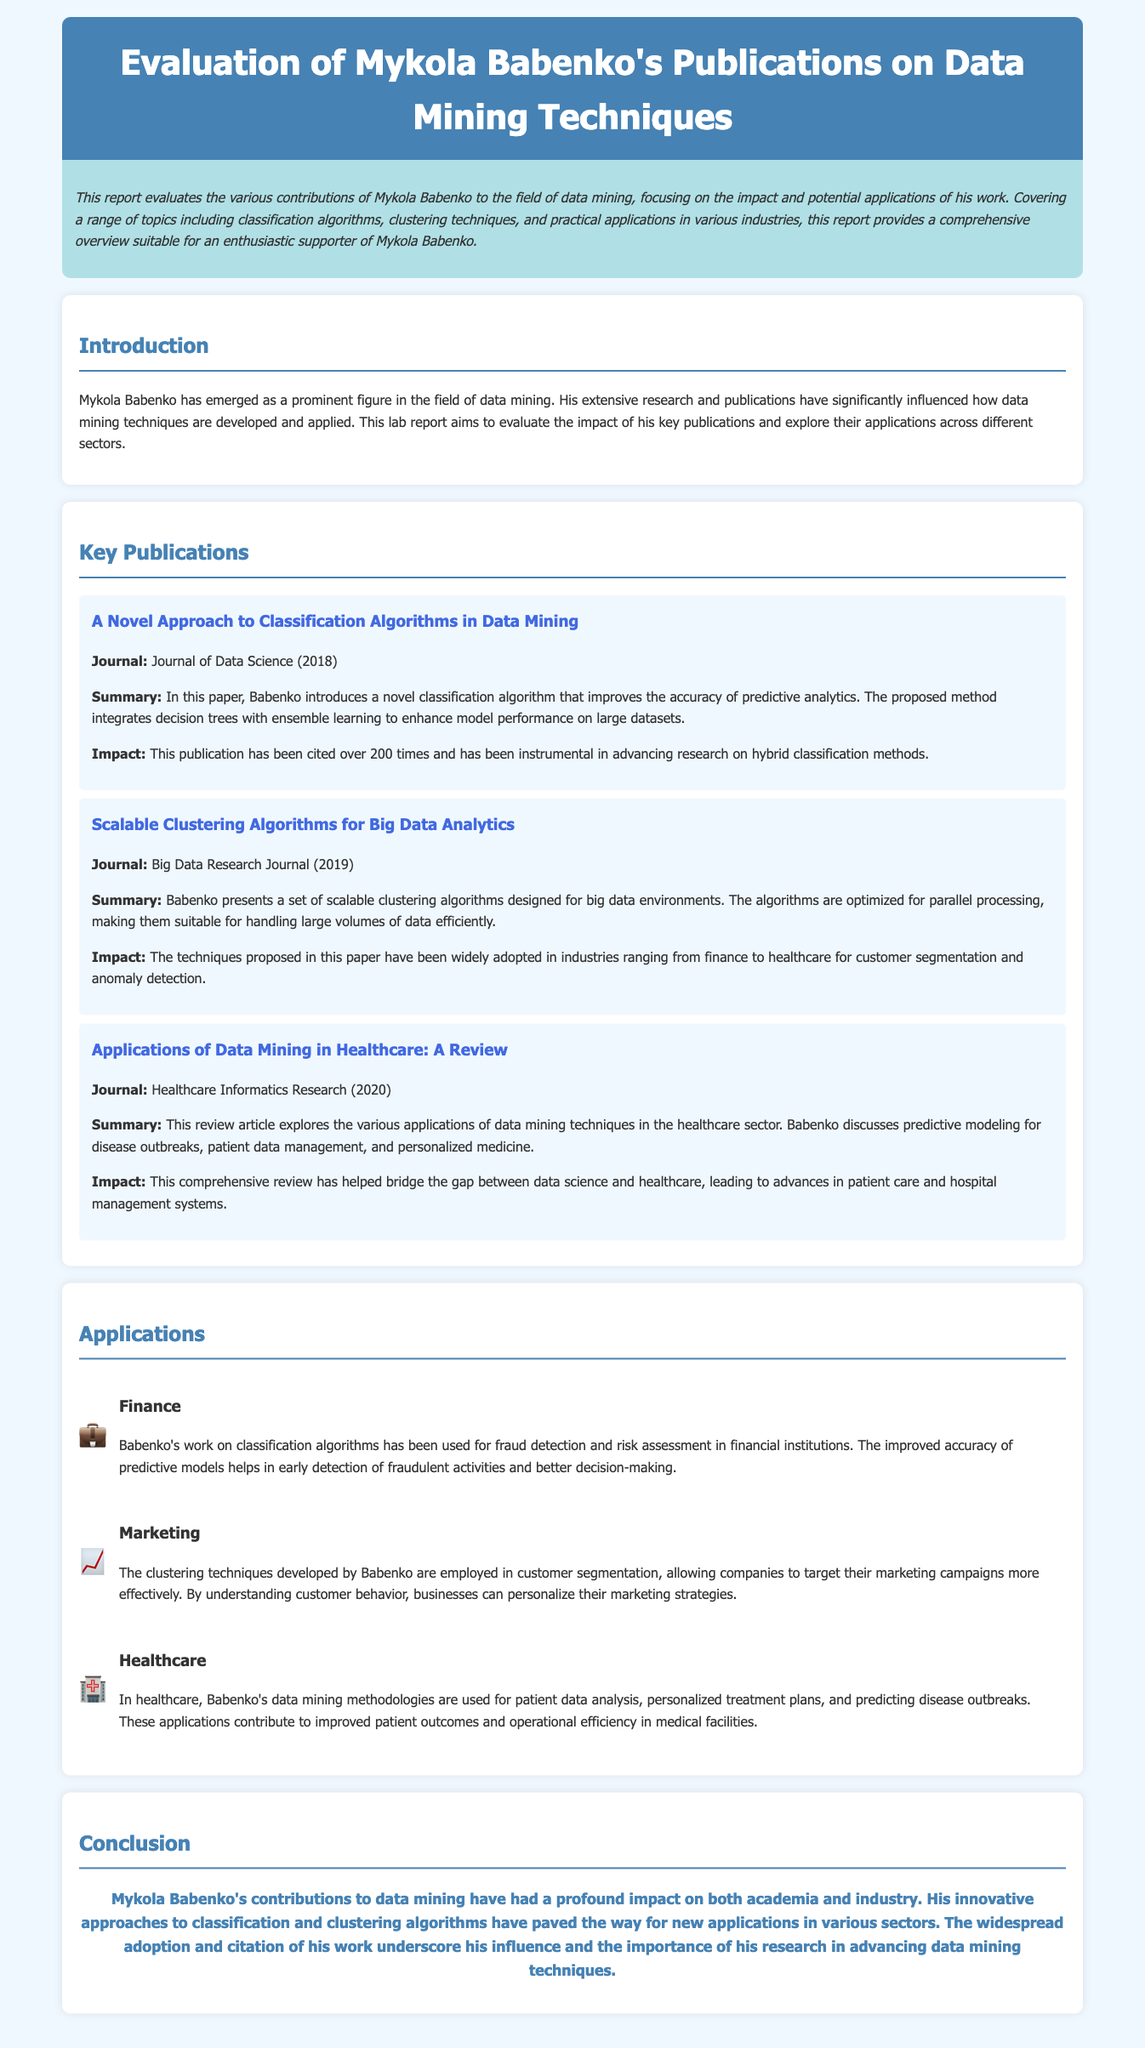What is the title of the lab report? The title of the lab report is presented at the beginning of the document, which is "Evaluation of Mykola Babenko's Publications on Data Mining Techniques".
Answer: Evaluation of Mykola Babenko's Publications on Data Mining Techniques In what year was the classification algorithm publication released? The publication on classification algorithms was published in the Journal of Data Science in the year mentioned in the document.
Answer: 2018 How many times has Babenko's novel classification algorithm publication been cited? The document states the citation count for Babenko's classification algorithm publication, which indicates its impact in the field.
Answer: over 200 times What is the application of Babenko's work in finance? The document specifies the application of Babenko's classification algorithms in finance, focusing on a specific function they serve in that industry.
Answer: fraud detection and risk assessment Which journal published Babenko's review on healthcare applications of data mining? The document identifies the journal where Babenko's review article on healthcare applications was published, reflecting its relevance in that sector.
Answer: Healthcare Informatics Research What is a key feature of Babenko's scalable clustering algorithms? The document outlines a specific characteristic of the clustering algorithms developed by Babenko that enhances their functionality in a specific context.
Answer: optimized for parallel processing What do Babenko's clustering techniques assist with in marketing? The document discusses a functional area in marketing where Babenko's techniques are utilized, which relates to how businesses engage with customers.
Answer: customer segmentation 